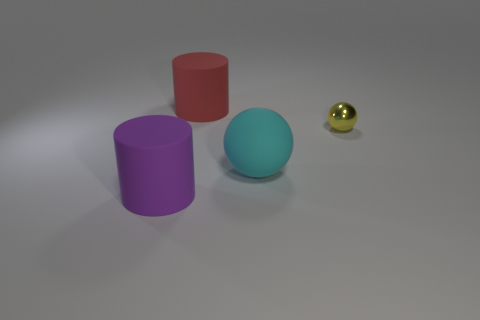Add 3 large blue shiny balls. How many objects exist? 7 Subtract 2 balls. How many balls are left? 0 Subtract all small green rubber objects. Subtract all large rubber spheres. How many objects are left? 3 Add 2 large cyan things. How many large cyan things are left? 3 Add 3 yellow metal things. How many yellow metal things exist? 4 Subtract 1 red cylinders. How many objects are left? 3 Subtract all cyan balls. Subtract all cyan cubes. How many balls are left? 1 Subtract all green cylinders. How many yellow balls are left? 1 